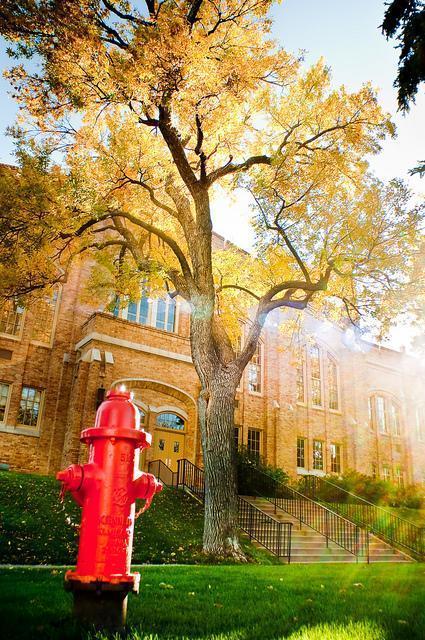How many zebras are facing forward?
Give a very brief answer. 0. 